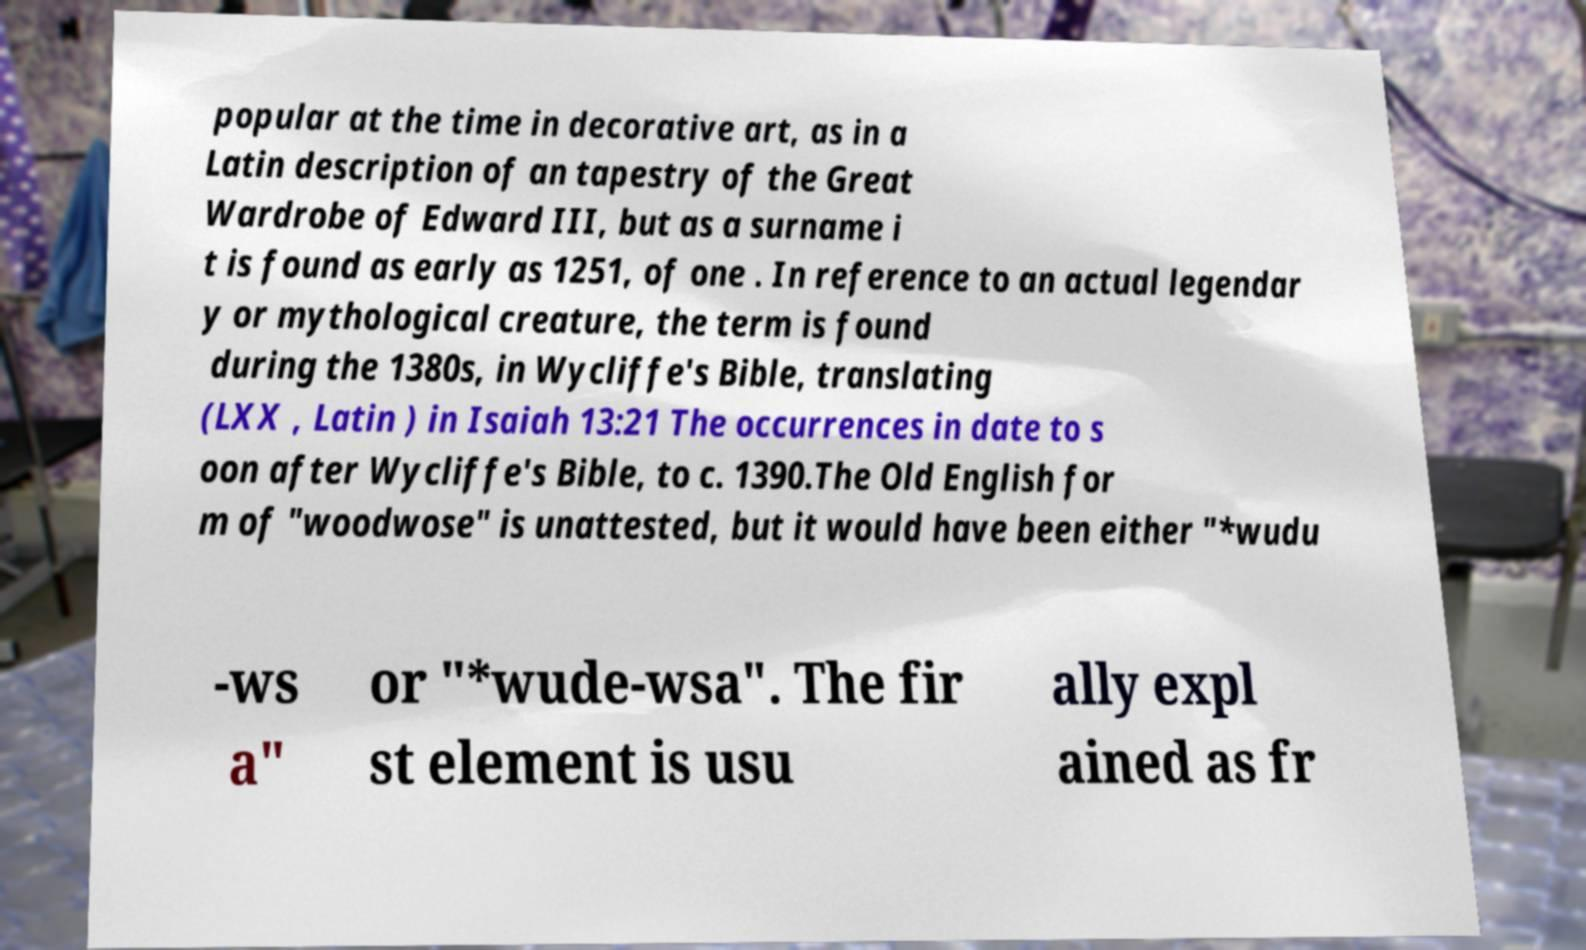Could you extract and type out the text from this image? popular at the time in decorative art, as in a Latin description of an tapestry of the Great Wardrobe of Edward III, but as a surname i t is found as early as 1251, of one . In reference to an actual legendar y or mythological creature, the term is found during the 1380s, in Wycliffe's Bible, translating (LXX , Latin ) in Isaiah 13:21 The occurrences in date to s oon after Wycliffe's Bible, to c. 1390.The Old English for m of "woodwose" is unattested, but it would have been either "*wudu -ws a" or "*wude-wsa". The fir st element is usu ally expl ained as fr 